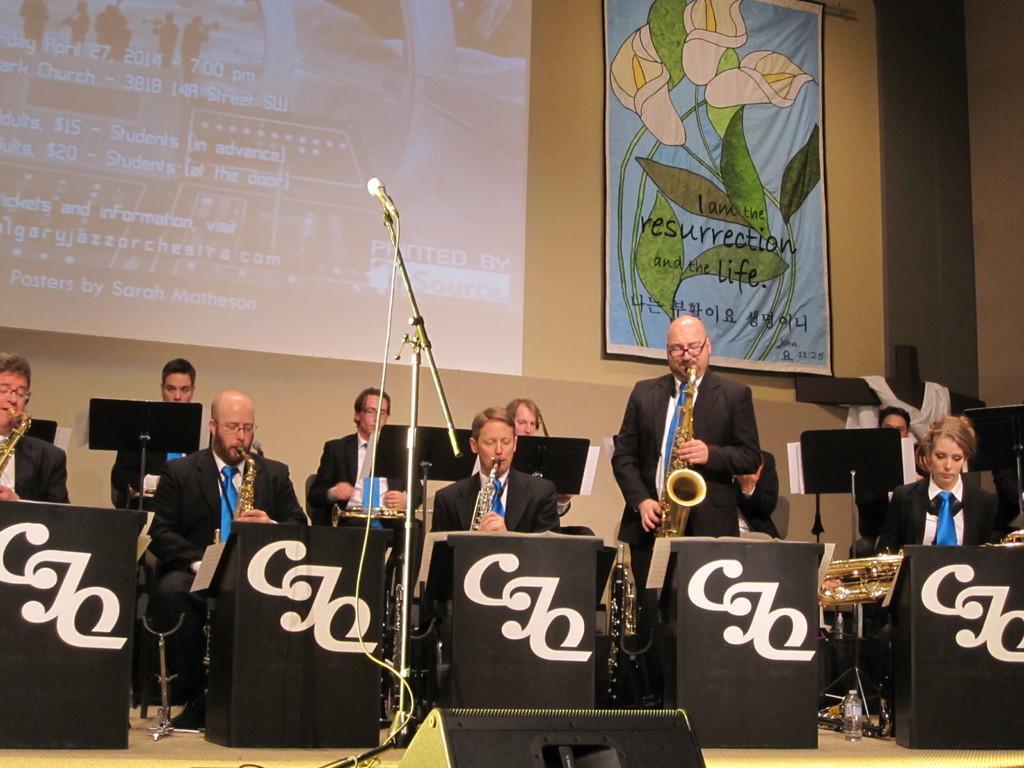Can you describe this image briefly? This picture is taken on a stage. All the people on the stage are playing musical instruments. In front of them, there are podiums and boards. In the center, there is a mike. Towards the left, there is a man playing a trumpet. All the people on the stage are wearing blazers. On the top, there is a screen and a frame with pictures and text. 